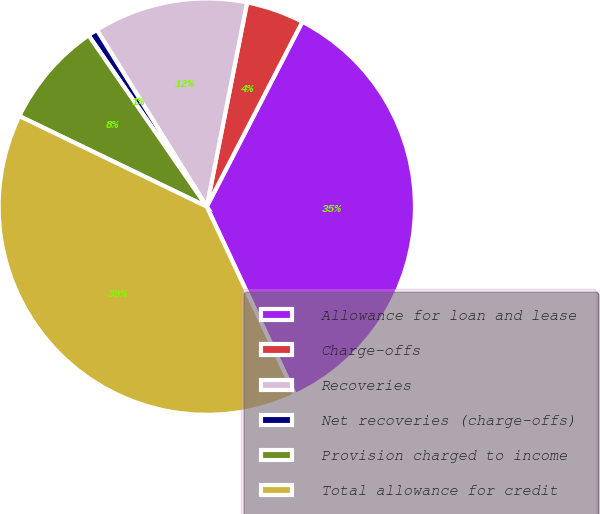Convert chart. <chart><loc_0><loc_0><loc_500><loc_500><pie_chart><fcel>Allowance for loan and lease<fcel>Charge-offs<fcel>Recoveries<fcel>Net recoveries (charge-offs)<fcel>Provision charged to income<fcel>Total allowance for credit<nl><fcel>35.42%<fcel>4.49%<fcel>11.96%<fcel>0.76%<fcel>8.22%<fcel>39.15%<nl></chart> 